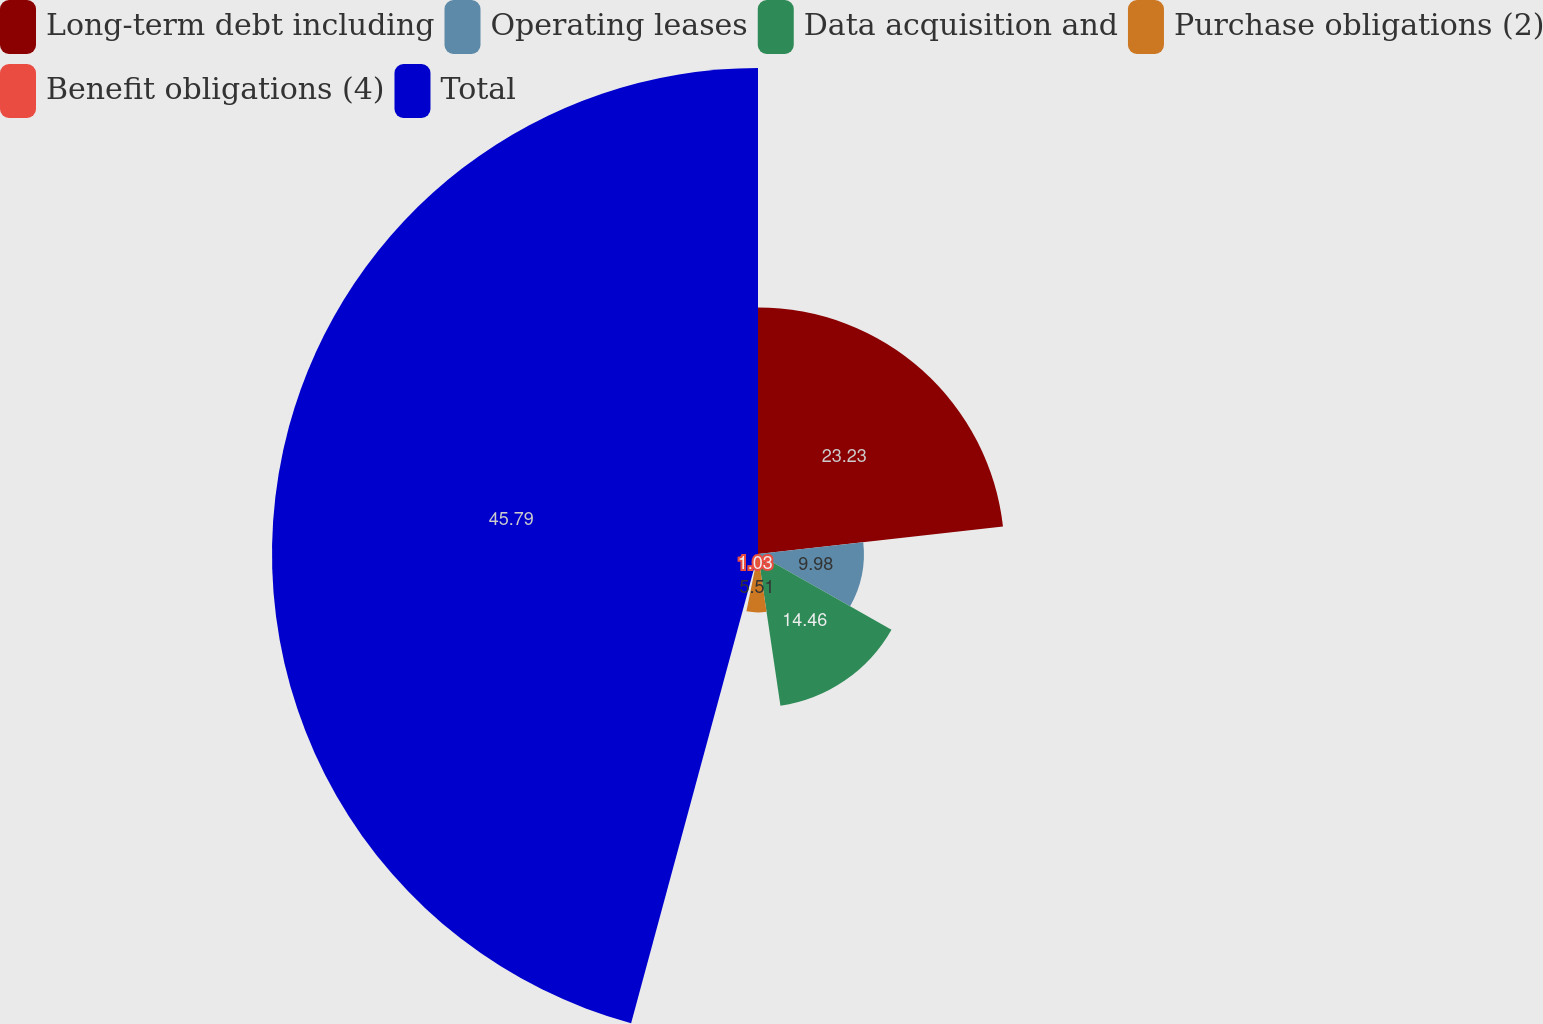Convert chart to OTSL. <chart><loc_0><loc_0><loc_500><loc_500><pie_chart><fcel>Long-term debt including<fcel>Operating leases<fcel>Data acquisition and<fcel>Purchase obligations (2)<fcel>Benefit obligations (4)<fcel>Total<nl><fcel>23.23%<fcel>9.98%<fcel>14.46%<fcel>5.51%<fcel>1.03%<fcel>45.8%<nl></chart> 